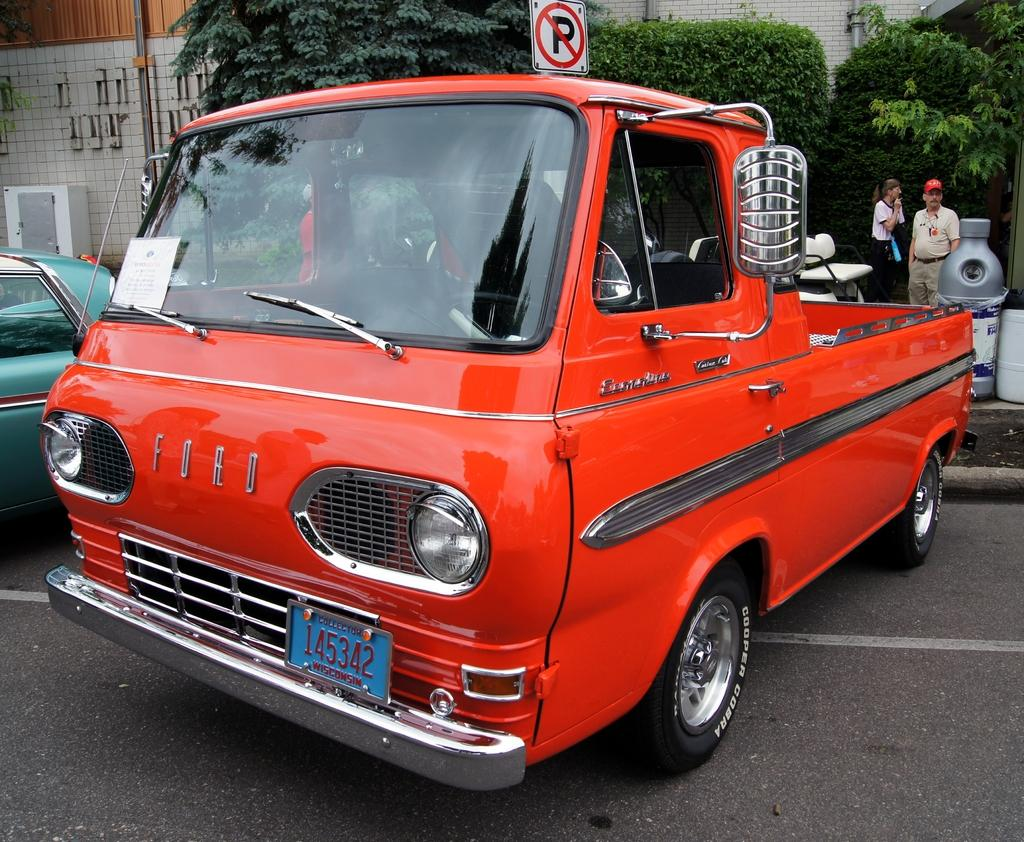<image>
Give a short and clear explanation of the subsequent image. A red truck with the licence plate number "145342". 